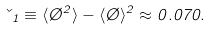Convert formula to latex. <formula><loc_0><loc_0><loc_500><loc_500>\kappa _ { 1 } \equiv \langle \chi ^ { 2 } \rangle - \langle \chi \rangle ^ { 2 } \approx 0 . 0 7 0 .</formula> 